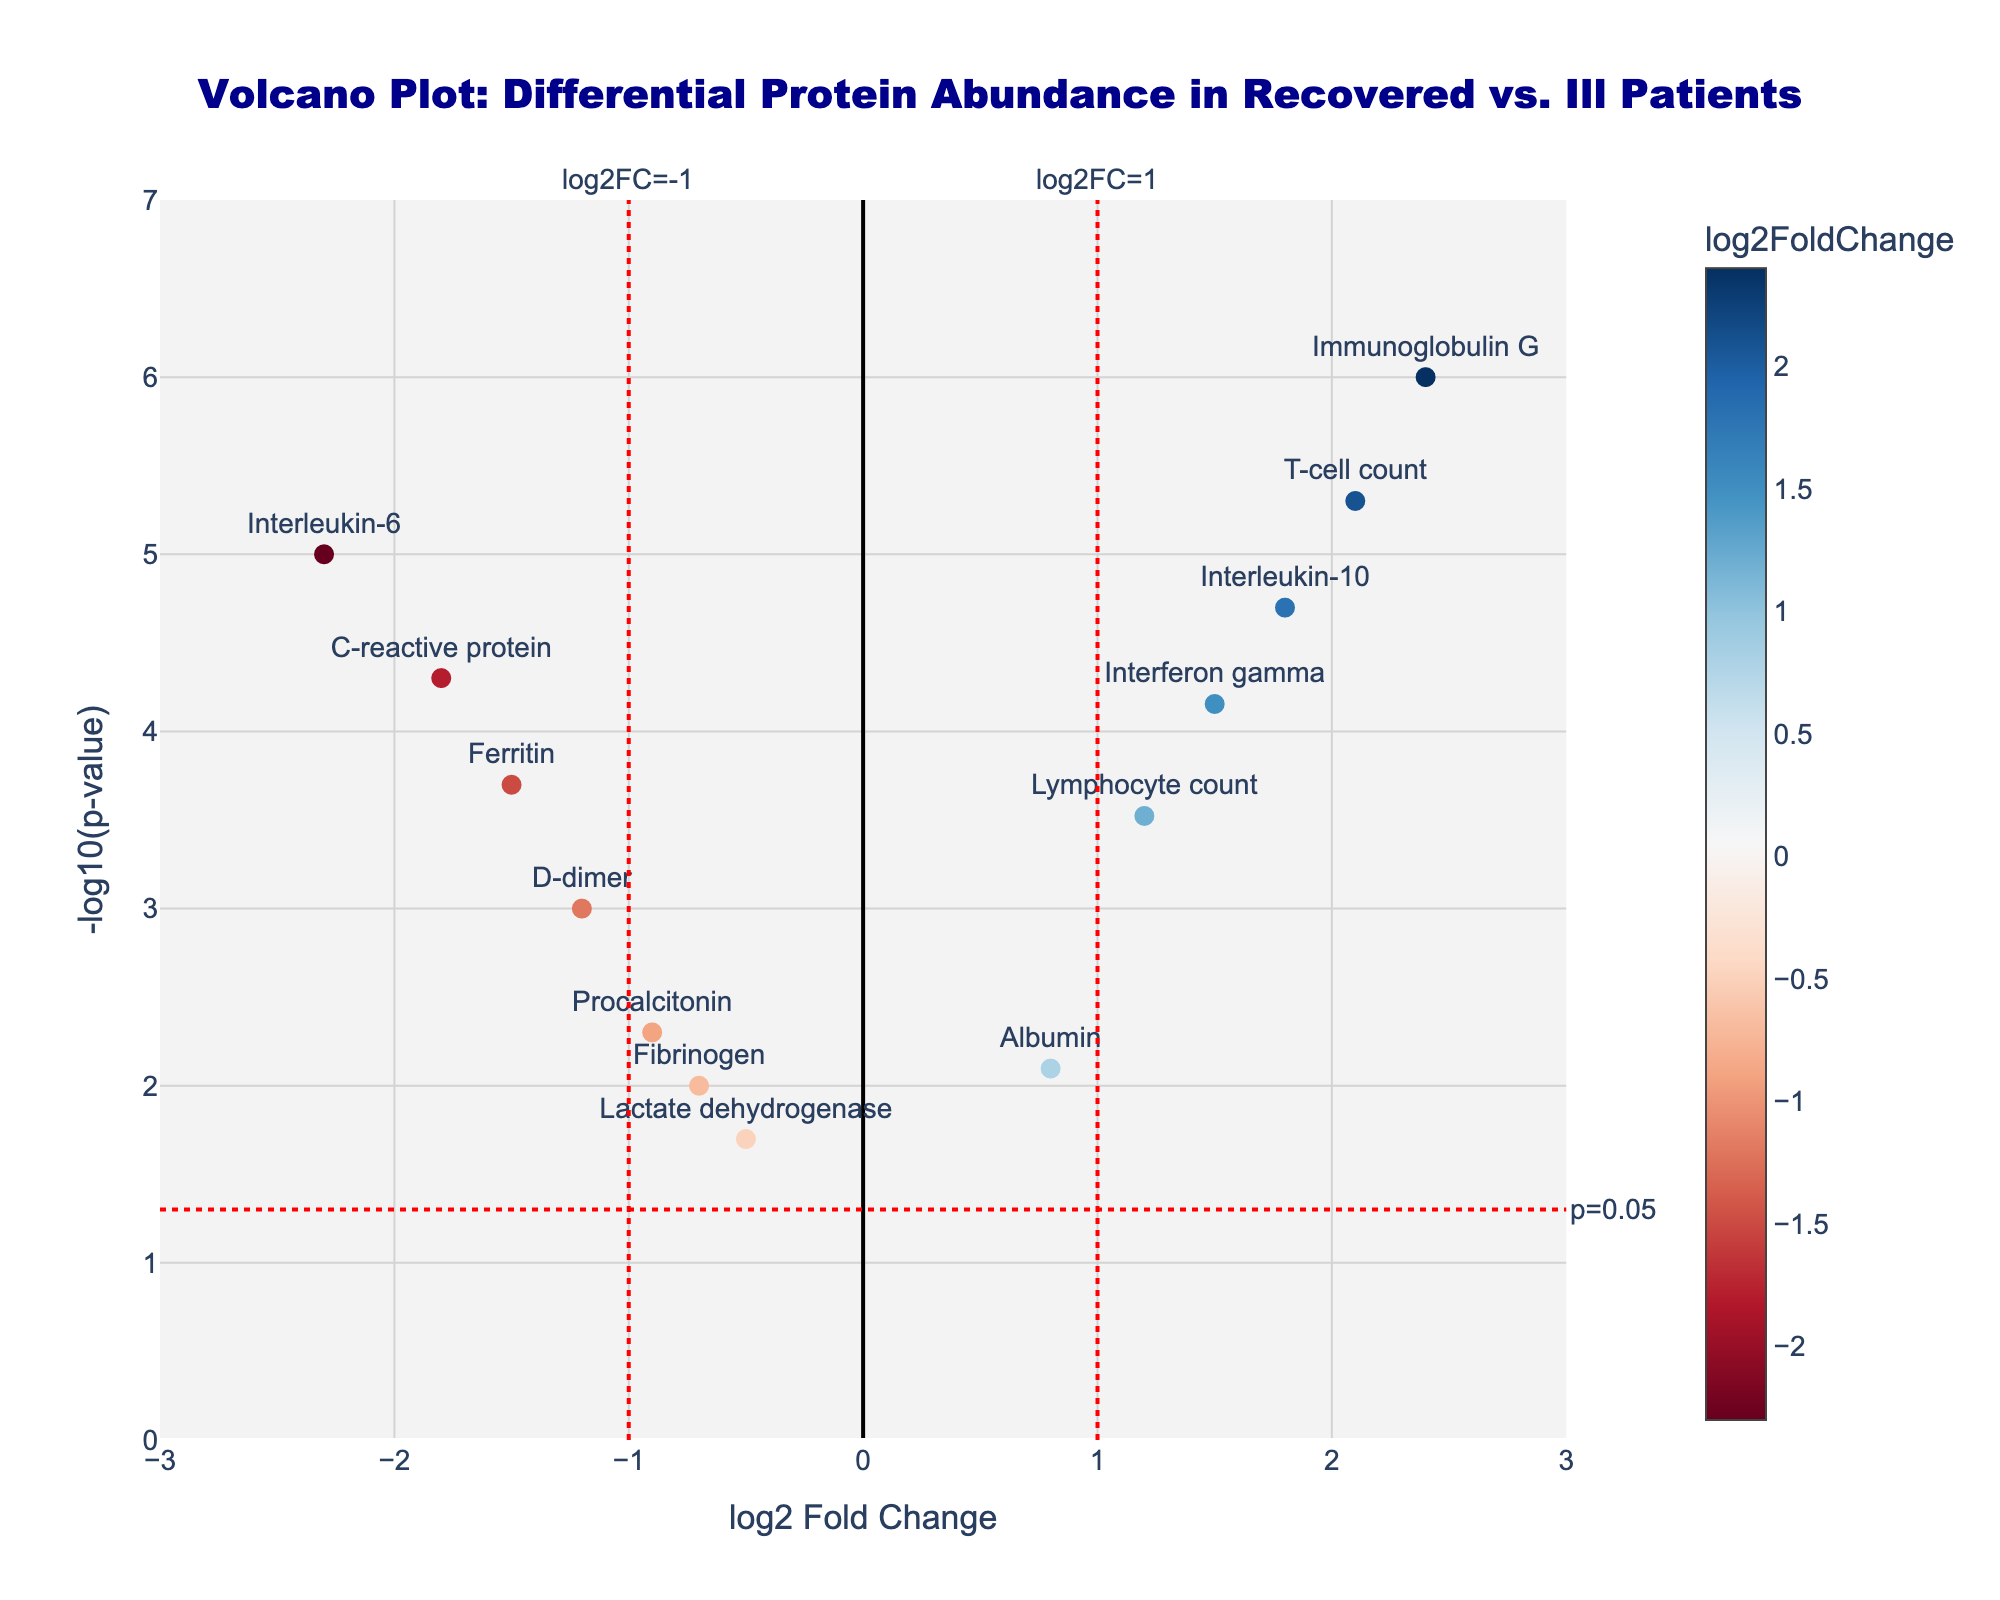How many data points are significantly different in the recovered patients compared to those still battling the illness? Count the number of points above the red horizontal line (p=0.05 threshold). Each of these points represents a protein with significant differential abundance.
Answer: 11 Which protein has the highest log2 fold change? Look for the protein with the highest x-axis value, indicating the highest positive log2 fold change.
Answer: Immunoglobulin G What is the p-value threshold indicated by the red horizontal line? The red horizontal line is labeled "p=0.05", indicating the p-value threshold at which significance is determined. The y-axis value of this line is -log10(0.05).
Answer: 0.05 How many proteins are downregulated in the recovered patients? Count the number of points to the left of the vertical red line at log2FC=-1. These points represent downregulated proteins.
Answer: 6 What is the log2 fold change of Interleukin-10? Locate the Interleukin-10 text on the plot and note its x-axis value, which represents its log2 fold change.
Answer: 1.8 Which protein has both a log2 fold change greater than 1 and a -log10(p-value) greater than 5? Find the points in the plot where the x-axis value is greater than 1 and the y-axis value is greater than 5. Identify the protein labels corresponding to these points.
Answer: Immunoglobulin G How does the abundance change of Albumin compare to Ferritin? Check the log2 fold change values of Albumin and Ferritin on the x-axis. Albumin has a log2 fold change of 0.8, while Ferritin has -1.5. Comparing these values tells us that Albumin is upregulated, and Ferritin is downregulated in recovered patients.
Answer: Albumin is upregulated, Ferritin is downregulated Which protein has a p-value closest to 0.001? Identify the point with the y-axis value nearest to -log10(0.001). The protein label for this point represents the protein with a p-value closest to 0.001.
Answer: D-dimer Are there any proteins with log2 fold change values between -1 and 1 that are not significantly different? Identify the data points between -1 and 1 on the x-axis and below the red horizontal line (p=0.05 threshold) on the y-axis, indicating a lack of significant difference.
Answer: Lactate dehydrogenase and Fibrinogen Which proteins have a negative log2 fold change and are significantly different? Look for points to the left of the red vertical line at log2FC = -1 and above the red horizontal line (p=0.05). These points represent significantly different and downregulated proteins.
Answer: Interleukin-6, C-reactive protein, Ferritin 